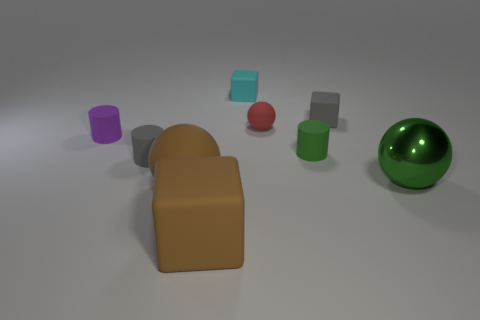Subtract all balls. How many objects are left? 6 Add 2 large rubber spheres. How many large rubber spheres exist? 3 Subtract 1 purple cylinders. How many objects are left? 8 Subtract all tiny purple cylinders. Subtract all gray rubber objects. How many objects are left? 6 Add 5 tiny green objects. How many tiny green objects are left? 6 